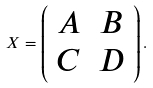Convert formula to latex. <formula><loc_0><loc_0><loc_500><loc_500>X = \left ( \begin{array} { c c } A & B \\ C & D \end{array} \right ) .</formula> 